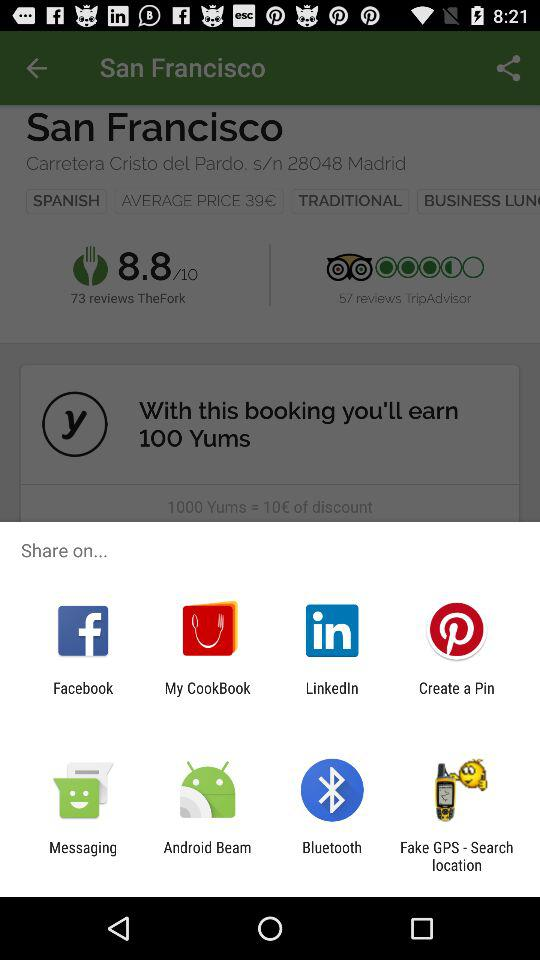How many more Yums do I need to earn to get a 10€ discount?
Answer the question using a single word or phrase. 900 